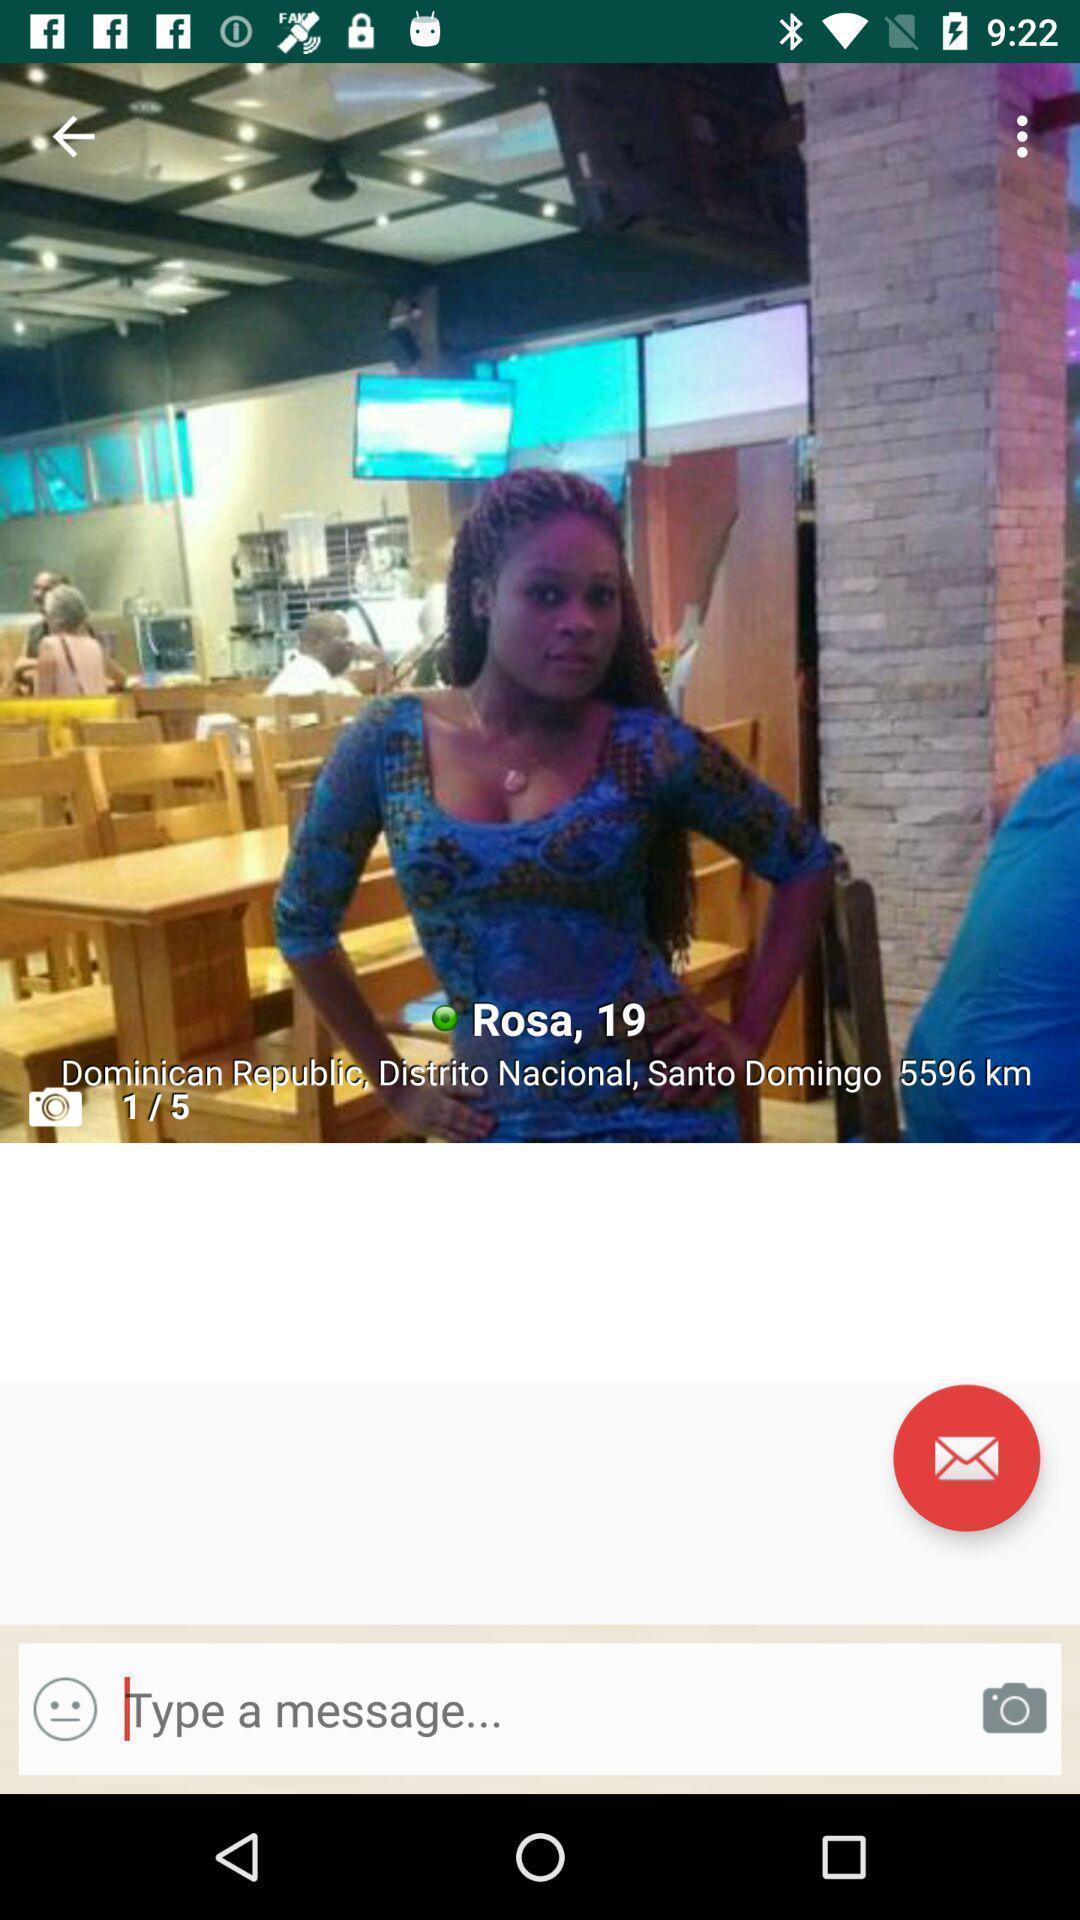Describe the visual elements of this screenshot. Profile page of a dating app. 